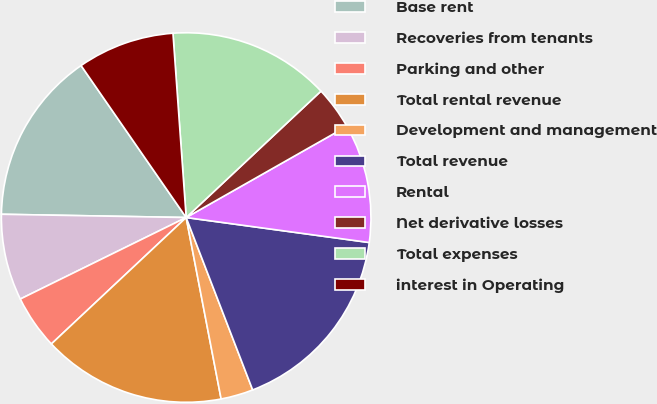Convert chart. <chart><loc_0><loc_0><loc_500><loc_500><pie_chart><fcel>Base rent<fcel>Recoveries from tenants<fcel>Parking and other<fcel>Total rental revenue<fcel>Development and management<fcel>Total revenue<fcel>Rental<fcel>Net derivative losses<fcel>Total expenses<fcel>interest in Operating<nl><fcel>15.09%<fcel>7.55%<fcel>4.72%<fcel>16.04%<fcel>2.83%<fcel>16.98%<fcel>10.38%<fcel>3.77%<fcel>14.15%<fcel>8.49%<nl></chart> 